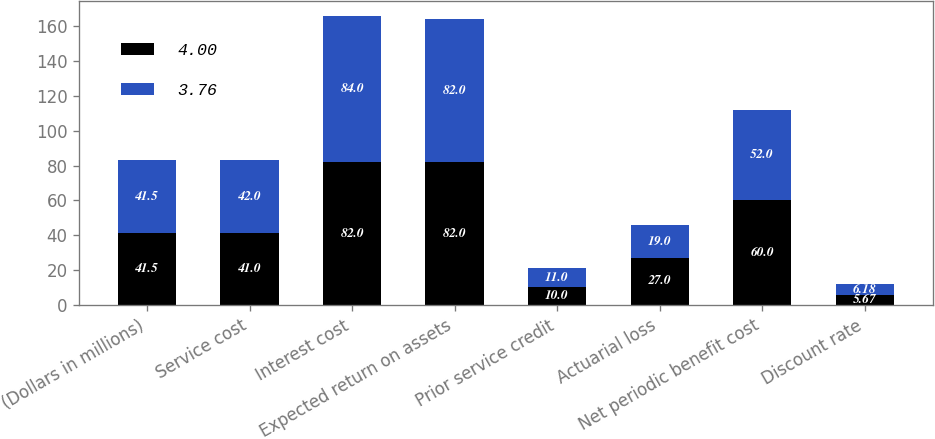<chart> <loc_0><loc_0><loc_500><loc_500><stacked_bar_chart><ecel><fcel>(Dollars in millions)<fcel>Service cost<fcel>Interest cost<fcel>Expected return on assets<fcel>Prior service credit<fcel>Actuarial loss<fcel>Net periodic benefit cost<fcel>Discount rate<nl><fcel>4<fcel>41.5<fcel>41<fcel>82<fcel>82<fcel>10<fcel>27<fcel>60<fcel>5.67<nl><fcel>3.76<fcel>41.5<fcel>42<fcel>84<fcel>82<fcel>11<fcel>19<fcel>52<fcel>6.18<nl></chart> 